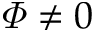<formula> <loc_0><loc_0><loc_500><loc_500>\varPhi \neq 0</formula> 